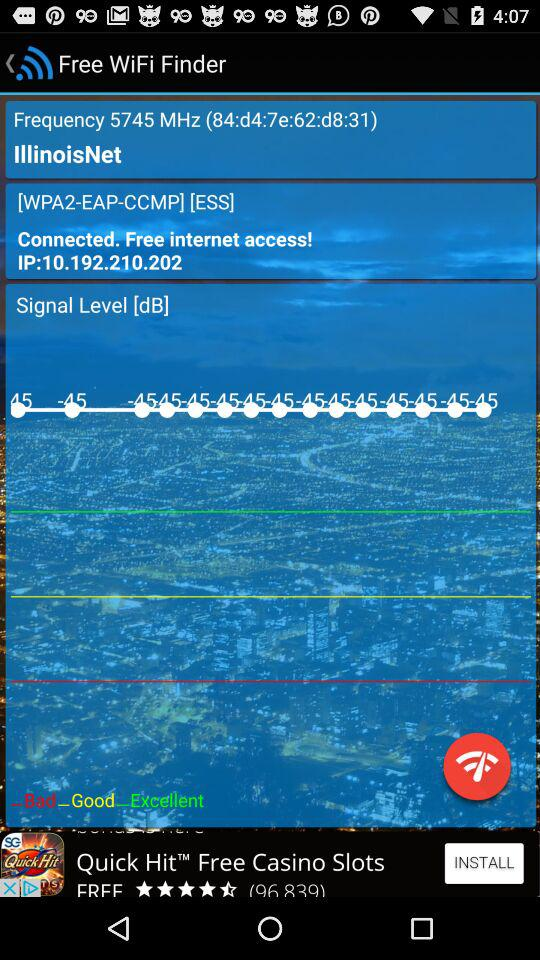What is the IP address? The IP address is 10.192.210.202. 